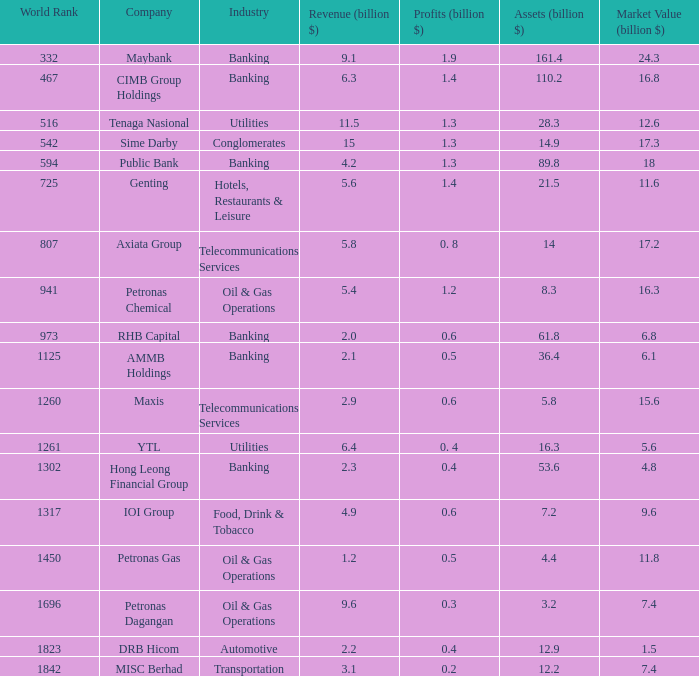Name the market value for rhb capital 6.8. 